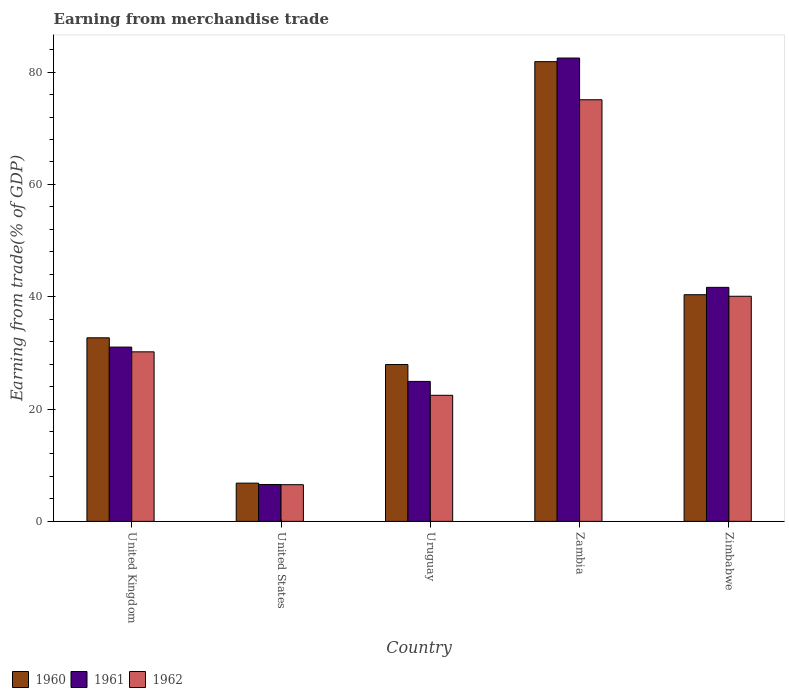How many different coloured bars are there?
Ensure brevity in your answer.  3. Are the number of bars on each tick of the X-axis equal?
Your answer should be very brief. Yes. What is the label of the 3rd group of bars from the left?
Offer a terse response. Uruguay. In how many cases, is the number of bars for a given country not equal to the number of legend labels?
Offer a terse response. 0. What is the earnings from trade in 1961 in Uruguay?
Offer a very short reply. 24.92. Across all countries, what is the maximum earnings from trade in 1961?
Your answer should be compact. 82.51. Across all countries, what is the minimum earnings from trade in 1961?
Your response must be concise. 6.57. In which country was the earnings from trade in 1961 maximum?
Make the answer very short. Zambia. What is the total earnings from trade in 1960 in the graph?
Provide a short and direct response. 189.65. What is the difference between the earnings from trade in 1960 in United States and that in Zimbabwe?
Provide a short and direct response. -33.55. What is the difference between the earnings from trade in 1961 in Zambia and the earnings from trade in 1962 in United Kingdom?
Make the answer very short. 52.32. What is the average earnings from trade in 1961 per country?
Your answer should be very brief. 37.34. What is the difference between the earnings from trade of/in 1960 and earnings from trade of/in 1962 in Zimbabwe?
Make the answer very short. 0.28. What is the ratio of the earnings from trade in 1962 in United States to that in Uruguay?
Ensure brevity in your answer.  0.29. Is the earnings from trade in 1961 in United Kingdom less than that in Zimbabwe?
Provide a succinct answer. Yes. Is the difference between the earnings from trade in 1960 in United Kingdom and Zimbabwe greater than the difference between the earnings from trade in 1962 in United Kingdom and Zimbabwe?
Your response must be concise. Yes. What is the difference between the highest and the second highest earnings from trade in 1960?
Your answer should be very brief. -41.5. What is the difference between the highest and the lowest earnings from trade in 1960?
Offer a terse response. 75.05. In how many countries, is the earnings from trade in 1960 greater than the average earnings from trade in 1960 taken over all countries?
Your answer should be very brief. 2. What does the 3rd bar from the left in United Kingdom represents?
Keep it short and to the point. 1962. How many bars are there?
Keep it short and to the point. 15. Are all the bars in the graph horizontal?
Ensure brevity in your answer.  No. What is the difference between two consecutive major ticks on the Y-axis?
Make the answer very short. 20. Does the graph contain any zero values?
Provide a succinct answer. No. Where does the legend appear in the graph?
Your answer should be compact. Bottom left. How many legend labels are there?
Keep it short and to the point. 3. What is the title of the graph?
Provide a short and direct response. Earning from merchandise trade. What is the label or title of the Y-axis?
Offer a very short reply. Earning from trade(% of GDP). What is the Earning from trade(% of GDP) in 1960 in United Kingdom?
Offer a very short reply. 32.69. What is the Earning from trade(% of GDP) of 1961 in United Kingdom?
Your answer should be very brief. 31.04. What is the Earning from trade(% of GDP) in 1962 in United Kingdom?
Your response must be concise. 30.19. What is the Earning from trade(% of GDP) of 1960 in United States?
Your answer should be very brief. 6.81. What is the Earning from trade(% of GDP) in 1961 in United States?
Keep it short and to the point. 6.57. What is the Earning from trade(% of GDP) of 1962 in United States?
Offer a terse response. 6.53. What is the Earning from trade(% of GDP) in 1960 in Uruguay?
Give a very brief answer. 27.93. What is the Earning from trade(% of GDP) in 1961 in Uruguay?
Provide a succinct answer. 24.92. What is the Earning from trade(% of GDP) of 1962 in Uruguay?
Your response must be concise. 22.45. What is the Earning from trade(% of GDP) in 1960 in Zambia?
Give a very brief answer. 81.86. What is the Earning from trade(% of GDP) in 1961 in Zambia?
Your response must be concise. 82.51. What is the Earning from trade(% of GDP) in 1962 in Zambia?
Offer a very short reply. 75.08. What is the Earning from trade(% of GDP) of 1960 in Zimbabwe?
Offer a terse response. 40.36. What is the Earning from trade(% of GDP) in 1961 in Zimbabwe?
Ensure brevity in your answer.  41.67. What is the Earning from trade(% of GDP) of 1962 in Zimbabwe?
Your response must be concise. 40.09. Across all countries, what is the maximum Earning from trade(% of GDP) in 1960?
Make the answer very short. 81.86. Across all countries, what is the maximum Earning from trade(% of GDP) of 1961?
Your response must be concise. 82.51. Across all countries, what is the maximum Earning from trade(% of GDP) of 1962?
Offer a terse response. 75.08. Across all countries, what is the minimum Earning from trade(% of GDP) of 1960?
Ensure brevity in your answer.  6.81. Across all countries, what is the minimum Earning from trade(% of GDP) of 1961?
Give a very brief answer. 6.57. Across all countries, what is the minimum Earning from trade(% of GDP) in 1962?
Make the answer very short. 6.53. What is the total Earning from trade(% of GDP) of 1960 in the graph?
Provide a short and direct response. 189.65. What is the total Earning from trade(% of GDP) of 1961 in the graph?
Your response must be concise. 186.71. What is the total Earning from trade(% of GDP) of 1962 in the graph?
Your answer should be compact. 174.33. What is the difference between the Earning from trade(% of GDP) of 1960 in United Kingdom and that in United States?
Provide a succinct answer. 25.88. What is the difference between the Earning from trade(% of GDP) in 1961 in United Kingdom and that in United States?
Your response must be concise. 24.47. What is the difference between the Earning from trade(% of GDP) of 1962 in United Kingdom and that in United States?
Your answer should be compact. 23.66. What is the difference between the Earning from trade(% of GDP) of 1960 in United Kingdom and that in Uruguay?
Your answer should be compact. 4.76. What is the difference between the Earning from trade(% of GDP) of 1961 in United Kingdom and that in Uruguay?
Ensure brevity in your answer.  6.11. What is the difference between the Earning from trade(% of GDP) of 1962 in United Kingdom and that in Uruguay?
Ensure brevity in your answer.  7.74. What is the difference between the Earning from trade(% of GDP) of 1960 in United Kingdom and that in Zambia?
Keep it short and to the point. -49.17. What is the difference between the Earning from trade(% of GDP) of 1961 in United Kingdom and that in Zambia?
Make the answer very short. -51.47. What is the difference between the Earning from trade(% of GDP) in 1962 in United Kingdom and that in Zambia?
Offer a terse response. -44.89. What is the difference between the Earning from trade(% of GDP) in 1960 in United Kingdom and that in Zimbabwe?
Provide a succinct answer. -7.67. What is the difference between the Earning from trade(% of GDP) in 1961 in United Kingdom and that in Zimbabwe?
Offer a very short reply. -10.64. What is the difference between the Earning from trade(% of GDP) of 1962 in United Kingdom and that in Zimbabwe?
Provide a succinct answer. -9.9. What is the difference between the Earning from trade(% of GDP) in 1960 in United States and that in Uruguay?
Your response must be concise. -21.12. What is the difference between the Earning from trade(% of GDP) in 1961 in United States and that in Uruguay?
Your answer should be very brief. -18.36. What is the difference between the Earning from trade(% of GDP) of 1962 in United States and that in Uruguay?
Provide a succinct answer. -15.92. What is the difference between the Earning from trade(% of GDP) in 1960 in United States and that in Zambia?
Offer a very short reply. -75.05. What is the difference between the Earning from trade(% of GDP) in 1961 in United States and that in Zambia?
Provide a short and direct response. -75.94. What is the difference between the Earning from trade(% of GDP) in 1962 in United States and that in Zambia?
Provide a short and direct response. -68.55. What is the difference between the Earning from trade(% of GDP) in 1960 in United States and that in Zimbabwe?
Ensure brevity in your answer.  -33.55. What is the difference between the Earning from trade(% of GDP) in 1961 in United States and that in Zimbabwe?
Provide a succinct answer. -35.11. What is the difference between the Earning from trade(% of GDP) in 1962 in United States and that in Zimbabwe?
Make the answer very short. -33.56. What is the difference between the Earning from trade(% of GDP) in 1960 in Uruguay and that in Zambia?
Make the answer very short. -53.93. What is the difference between the Earning from trade(% of GDP) of 1961 in Uruguay and that in Zambia?
Your answer should be very brief. -57.59. What is the difference between the Earning from trade(% of GDP) in 1962 in Uruguay and that in Zambia?
Keep it short and to the point. -52.63. What is the difference between the Earning from trade(% of GDP) in 1960 in Uruguay and that in Zimbabwe?
Provide a short and direct response. -12.43. What is the difference between the Earning from trade(% of GDP) in 1961 in Uruguay and that in Zimbabwe?
Offer a very short reply. -16.75. What is the difference between the Earning from trade(% of GDP) in 1962 in Uruguay and that in Zimbabwe?
Provide a short and direct response. -17.64. What is the difference between the Earning from trade(% of GDP) in 1960 in Zambia and that in Zimbabwe?
Give a very brief answer. 41.5. What is the difference between the Earning from trade(% of GDP) of 1961 in Zambia and that in Zimbabwe?
Give a very brief answer. 40.84. What is the difference between the Earning from trade(% of GDP) in 1962 in Zambia and that in Zimbabwe?
Give a very brief answer. 34.99. What is the difference between the Earning from trade(% of GDP) in 1960 in United Kingdom and the Earning from trade(% of GDP) in 1961 in United States?
Give a very brief answer. 26.12. What is the difference between the Earning from trade(% of GDP) of 1960 in United Kingdom and the Earning from trade(% of GDP) of 1962 in United States?
Provide a short and direct response. 26.16. What is the difference between the Earning from trade(% of GDP) in 1961 in United Kingdom and the Earning from trade(% of GDP) in 1962 in United States?
Keep it short and to the point. 24.51. What is the difference between the Earning from trade(% of GDP) in 1960 in United Kingdom and the Earning from trade(% of GDP) in 1961 in Uruguay?
Offer a terse response. 7.77. What is the difference between the Earning from trade(% of GDP) of 1960 in United Kingdom and the Earning from trade(% of GDP) of 1962 in Uruguay?
Provide a short and direct response. 10.24. What is the difference between the Earning from trade(% of GDP) in 1961 in United Kingdom and the Earning from trade(% of GDP) in 1962 in Uruguay?
Provide a short and direct response. 8.59. What is the difference between the Earning from trade(% of GDP) of 1960 in United Kingdom and the Earning from trade(% of GDP) of 1961 in Zambia?
Ensure brevity in your answer.  -49.82. What is the difference between the Earning from trade(% of GDP) of 1960 in United Kingdom and the Earning from trade(% of GDP) of 1962 in Zambia?
Offer a terse response. -42.39. What is the difference between the Earning from trade(% of GDP) of 1961 in United Kingdom and the Earning from trade(% of GDP) of 1962 in Zambia?
Your answer should be very brief. -44.04. What is the difference between the Earning from trade(% of GDP) of 1960 in United Kingdom and the Earning from trade(% of GDP) of 1961 in Zimbabwe?
Provide a succinct answer. -8.98. What is the difference between the Earning from trade(% of GDP) of 1960 in United Kingdom and the Earning from trade(% of GDP) of 1962 in Zimbabwe?
Your answer should be compact. -7.4. What is the difference between the Earning from trade(% of GDP) in 1961 in United Kingdom and the Earning from trade(% of GDP) in 1962 in Zimbabwe?
Provide a succinct answer. -9.05. What is the difference between the Earning from trade(% of GDP) of 1960 in United States and the Earning from trade(% of GDP) of 1961 in Uruguay?
Ensure brevity in your answer.  -18.12. What is the difference between the Earning from trade(% of GDP) of 1960 in United States and the Earning from trade(% of GDP) of 1962 in Uruguay?
Give a very brief answer. -15.64. What is the difference between the Earning from trade(% of GDP) in 1961 in United States and the Earning from trade(% of GDP) in 1962 in Uruguay?
Offer a terse response. -15.88. What is the difference between the Earning from trade(% of GDP) of 1960 in United States and the Earning from trade(% of GDP) of 1961 in Zambia?
Your answer should be compact. -75.7. What is the difference between the Earning from trade(% of GDP) of 1960 in United States and the Earning from trade(% of GDP) of 1962 in Zambia?
Your response must be concise. -68.27. What is the difference between the Earning from trade(% of GDP) in 1961 in United States and the Earning from trade(% of GDP) in 1962 in Zambia?
Your answer should be very brief. -68.51. What is the difference between the Earning from trade(% of GDP) in 1960 in United States and the Earning from trade(% of GDP) in 1961 in Zimbabwe?
Keep it short and to the point. -34.87. What is the difference between the Earning from trade(% of GDP) in 1960 in United States and the Earning from trade(% of GDP) in 1962 in Zimbabwe?
Make the answer very short. -33.28. What is the difference between the Earning from trade(% of GDP) of 1961 in United States and the Earning from trade(% of GDP) of 1962 in Zimbabwe?
Your response must be concise. -33.52. What is the difference between the Earning from trade(% of GDP) in 1960 in Uruguay and the Earning from trade(% of GDP) in 1961 in Zambia?
Your response must be concise. -54.58. What is the difference between the Earning from trade(% of GDP) in 1960 in Uruguay and the Earning from trade(% of GDP) in 1962 in Zambia?
Give a very brief answer. -47.15. What is the difference between the Earning from trade(% of GDP) of 1961 in Uruguay and the Earning from trade(% of GDP) of 1962 in Zambia?
Ensure brevity in your answer.  -50.16. What is the difference between the Earning from trade(% of GDP) of 1960 in Uruguay and the Earning from trade(% of GDP) of 1961 in Zimbabwe?
Your response must be concise. -13.74. What is the difference between the Earning from trade(% of GDP) in 1960 in Uruguay and the Earning from trade(% of GDP) in 1962 in Zimbabwe?
Make the answer very short. -12.16. What is the difference between the Earning from trade(% of GDP) in 1961 in Uruguay and the Earning from trade(% of GDP) in 1962 in Zimbabwe?
Your response must be concise. -15.16. What is the difference between the Earning from trade(% of GDP) in 1960 in Zambia and the Earning from trade(% of GDP) in 1961 in Zimbabwe?
Make the answer very short. 40.19. What is the difference between the Earning from trade(% of GDP) of 1960 in Zambia and the Earning from trade(% of GDP) of 1962 in Zimbabwe?
Your response must be concise. 41.78. What is the difference between the Earning from trade(% of GDP) of 1961 in Zambia and the Earning from trade(% of GDP) of 1962 in Zimbabwe?
Your answer should be compact. 42.42. What is the average Earning from trade(% of GDP) in 1960 per country?
Offer a terse response. 37.93. What is the average Earning from trade(% of GDP) in 1961 per country?
Provide a short and direct response. 37.34. What is the average Earning from trade(% of GDP) in 1962 per country?
Offer a terse response. 34.87. What is the difference between the Earning from trade(% of GDP) of 1960 and Earning from trade(% of GDP) of 1961 in United Kingdom?
Your answer should be very brief. 1.65. What is the difference between the Earning from trade(% of GDP) of 1960 and Earning from trade(% of GDP) of 1962 in United Kingdom?
Your response must be concise. 2.5. What is the difference between the Earning from trade(% of GDP) of 1961 and Earning from trade(% of GDP) of 1962 in United Kingdom?
Ensure brevity in your answer.  0.85. What is the difference between the Earning from trade(% of GDP) of 1960 and Earning from trade(% of GDP) of 1961 in United States?
Your answer should be very brief. 0.24. What is the difference between the Earning from trade(% of GDP) in 1960 and Earning from trade(% of GDP) in 1962 in United States?
Ensure brevity in your answer.  0.28. What is the difference between the Earning from trade(% of GDP) of 1961 and Earning from trade(% of GDP) of 1962 in United States?
Offer a very short reply. 0.04. What is the difference between the Earning from trade(% of GDP) in 1960 and Earning from trade(% of GDP) in 1961 in Uruguay?
Your answer should be compact. 3. What is the difference between the Earning from trade(% of GDP) in 1960 and Earning from trade(% of GDP) in 1962 in Uruguay?
Keep it short and to the point. 5.48. What is the difference between the Earning from trade(% of GDP) of 1961 and Earning from trade(% of GDP) of 1962 in Uruguay?
Your answer should be compact. 2.47. What is the difference between the Earning from trade(% of GDP) in 1960 and Earning from trade(% of GDP) in 1961 in Zambia?
Make the answer very short. -0.65. What is the difference between the Earning from trade(% of GDP) of 1960 and Earning from trade(% of GDP) of 1962 in Zambia?
Offer a very short reply. 6.78. What is the difference between the Earning from trade(% of GDP) in 1961 and Earning from trade(% of GDP) in 1962 in Zambia?
Your response must be concise. 7.43. What is the difference between the Earning from trade(% of GDP) of 1960 and Earning from trade(% of GDP) of 1961 in Zimbabwe?
Offer a terse response. -1.31. What is the difference between the Earning from trade(% of GDP) of 1960 and Earning from trade(% of GDP) of 1962 in Zimbabwe?
Your response must be concise. 0.28. What is the difference between the Earning from trade(% of GDP) of 1961 and Earning from trade(% of GDP) of 1962 in Zimbabwe?
Offer a terse response. 1.59. What is the ratio of the Earning from trade(% of GDP) in 1960 in United Kingdom to that in United States?
Make the answer very short. 4.8. What is the ratio of the Earning from trade(% of GDP) of 1961 in United Kingdom to that in United States?
Ensure brevity in your answer.  4.73. What is the ratio of the Earning from trade(% of GDP) of 1962 in United Kingdom to that in United States?
Your answer should be very brief. 4.62. What is the ratio of the Earning from trade(% of GDP) of 1960 in United Kingdom to that in Uruguay?
Keep it short and to the point. 1.17. What is the ratio of the Earning from trade(% of GDP) of 1961 in United Kingdom to that in Uruguay?
Your response must be concise. 1.25. What is the ratio of the Earning from trade(% of GDP) of 1962 in United Kingdom to that in Uruguay?
Keep it short and to the point. 1.34. What is the ratio of the Earning from trade(% of GDP) of 1960 in United Kingdom to that in Zambia?
Your answer should be very brief. 0.4. What is the ratio of the Earning from trade(% of GDP) in 1961 in United Kingdom to that in Zambia?
Provide a succinct answer. 0.38. What is the ratio of the Earning from trade(% of GDP) of 1962 in United Kingdom to that in Zambia?
Offer a terse response. 0.4. What is the ratio of the Earning from trade(% of GDP) of 1960 in United Kingdom to that in Zimbabwe?
Provide a succinct answer. 0.81. What is the ratio of the Earning from trade(% of GDP) of 1961 in United Kingdom to that in Zimbabwe?
Offer a terse response. 0.74. What is the ratio of the Earning from trade(% of GDP) of 1962 in United Kingdom to that in Zimbabwe?
Provide a short and direct response. 0.75. What is the ratio of the Earning from trade(% of GDP) in 1960 in United States to that in Uruguay?
Offer a very short reply. 0.24. What is the ratio of the Earning from trade(% of GDP) in 1961 in United States to that in Uruguay?
Your answer should be compact. 0.26. What is the ratio of the Earning from trade(% of GDP) of 1962 in United States to that in Uruguay?
Your answer should be compact. 0.29. What is the ratio of the Earning from trade(% of GDP) in 1960 in United States to that in Zambia?
Provide a short and direct response. 0.08. What is the ratio of the Earning from trade(% of GDP) in 1961 in United States to that in Zambia?
Provide a succinct answer. 0.08. What is the ratio of the Earning from trade(% of GDP) in 1962 in United States to that in Zambia?
Provide a succinct answer. 0.09. What is the ratio of the Earning from trade(% of GDP) of 1960 in United States to that in Zimbabwe?
Your response must be concise. 0.17. What is the ratio of the Earning from trade(% of GDP) of 1961 in United States to that in Zimbabwe?
Provide a short and direct response. 0.16. What is the ratio of the Earning from trade(% of GDP) of 1962 in United States to that in Zimbabwe?
Provide a succinct answer. 0.16. What is the ratio of the Earning from trade(% of GDP) in 1960 in Uruguay to that in Zambia?
Give a very brief answer. 0.34. What is the ratio of the Earning from trade(% of GDP) in 1961 in Uruguay to that in Zambia?
Provide a short and direct response. 0.3. What is the ratio of the Earning from trade(% of GDP) in 1962 in Uruguay to that in Zambia?
Make the answer very short. 0.3. What is the ratio of the Earning from trade(% of GDP) in 1960 in Uruguay to that in Zimbabwe?
Ensure brevity in your answer.  0.69. What is the ratio of the Earning from trade(% of GDP) of 1961 in Uruguay to that in Zimbabwe?
Your response must be concise. 0.6. What is the ratio of the Earning from trade(% of GDP) in 1962 in Uruguay to that in Zimbabwe?
Offer a terse response. 0.56. What is the ratio of the Earning from trade(% of GDP) of 1960 in Zambia to that in Zimbabwe?
Your answer should be compact. 2.03. What is the ratio of the Earning from trade(% of GDP) in 1961 in Zambia to that in Zimbabwe?
Provide a succinct answer. 1.98. What is the ratio of the Earning from trade(% of GDP) in 1962 in Zambia to that in Zimbabwe?
Your answer should be compact. 1.87. What is the difference between the highest and the second highest Earning from trade(% of GDP) in 1960?
Provide a succinct answer. 41.5. What is the difference between the highest and the second highest Earning from trade(% of GDP) of 1961?
Your response must be concise. 40.84. What is the difference between the highest and the second highest Earning from trade(% of GDP) of 1962?
Ensure brevity in your answer.  34.99. What is the difference between the highest and the lowest Earning from trade(% of GDP) in 1960?
Your answer should be compact. 75.05. What is the difference between the highest and the lowest Earning from trade(% of GDP) of 1961?
Provide a short and direct response. 75.94. What is the difference between the highest and the lowest Earning from trade(% of GDP) in 1962?
Provide a succinct answer. 68.55. 